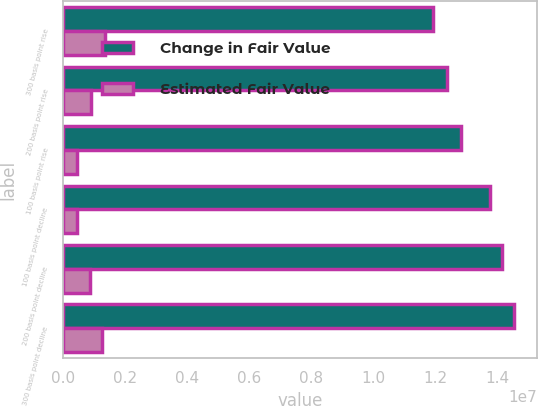Convert chart to OTSL. <chart><loc_0><loc_0><loc_500><loc_500><stacked_bar_chart><ecel><fcel>300 basis point rise<fcel>200 basis point rise<fcel>100 basis point rise<fcel>100 basis point decline<fcel>200 basis point decline<fcel>300 basis point decline<nl><fcel>Change in Fair Value<fcel>1.19277e+07<fcel>1.23586e+07<fcel>1.28096e+07<fcel>1.37411e+07<fcel>1.41543e+07<fcel>1.4537e+07<nl><fcel>Estimated Fair Value<fcel>1.35277e+06<fcel>921903<fcel>470866<fcel>460615<fcel>873853<fcel>1.25653e+06<nl></chart> 